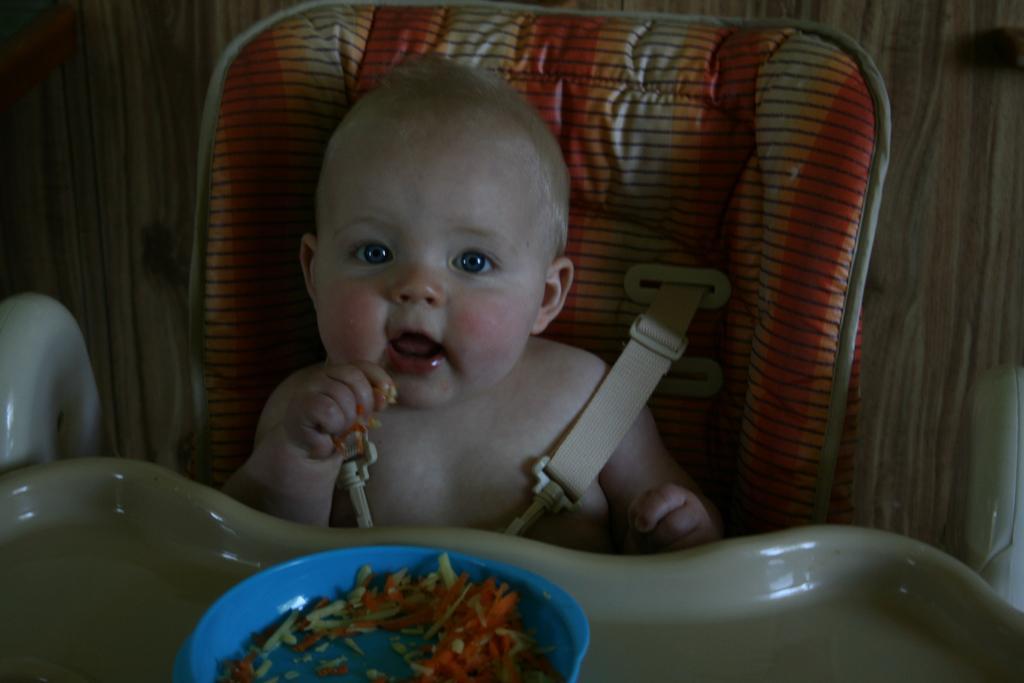Can you describe this image briefly? In the middle of the image we can see a baby is seated on the chair, in front of the baby we can find food in the bowl. 